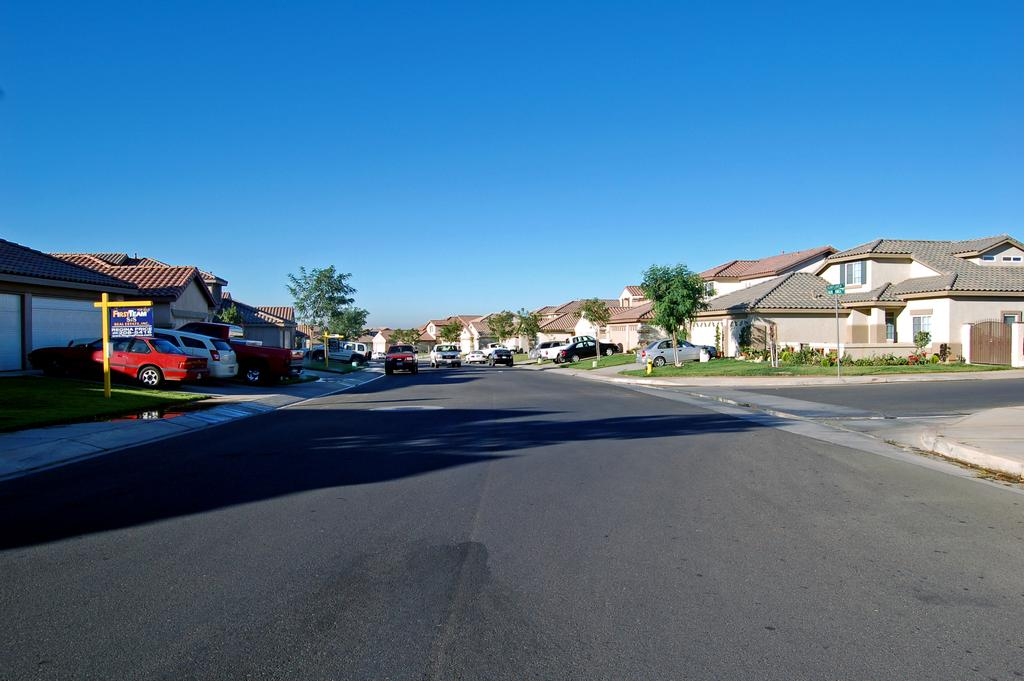What types of objects can be seen in the image? There are vehicles, trees, and buildings in the image. What is the color of the trees in the image? The trees in the image are green. What colors are the buildings in the image? The buildings in the image are white and cream-colored. What is the color of the sky in the image? The sky in the image is blue. Can you tell me how many beginner firemen are standing near the sand in the image? There is no sand, beginner firemen, or any firemen present in the image. 